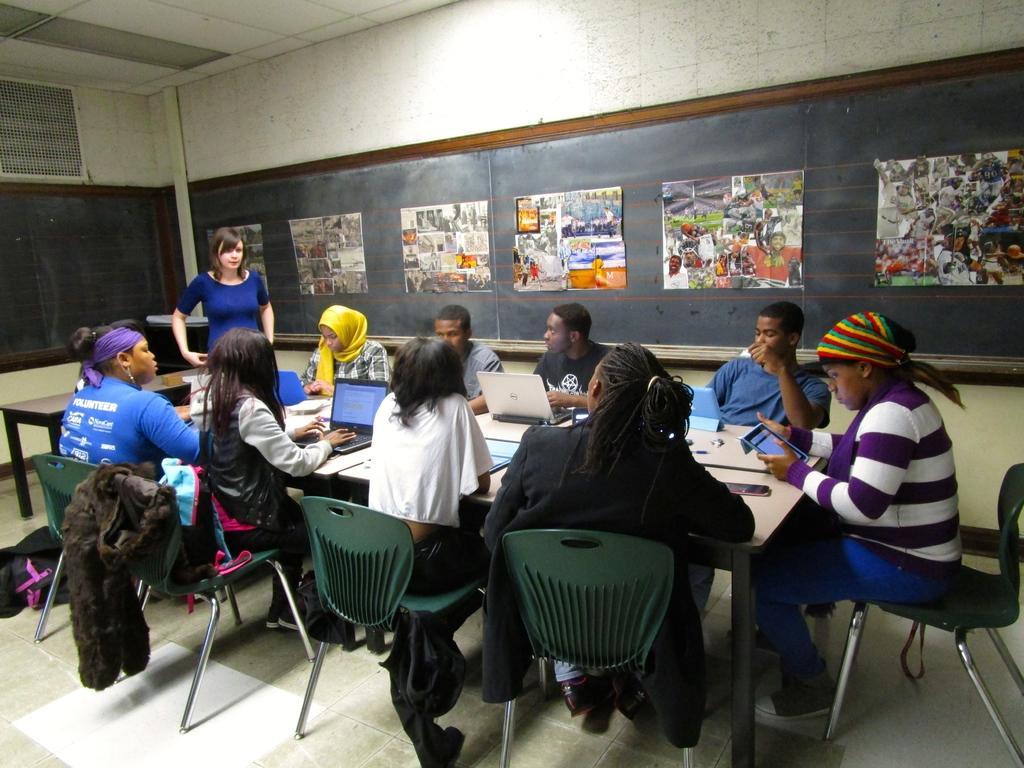Could you give a brief overview of what you see in this image? In this image we can see many people are sitting on the chairs around a table. We can see laptops, blackboards with charts on it. 